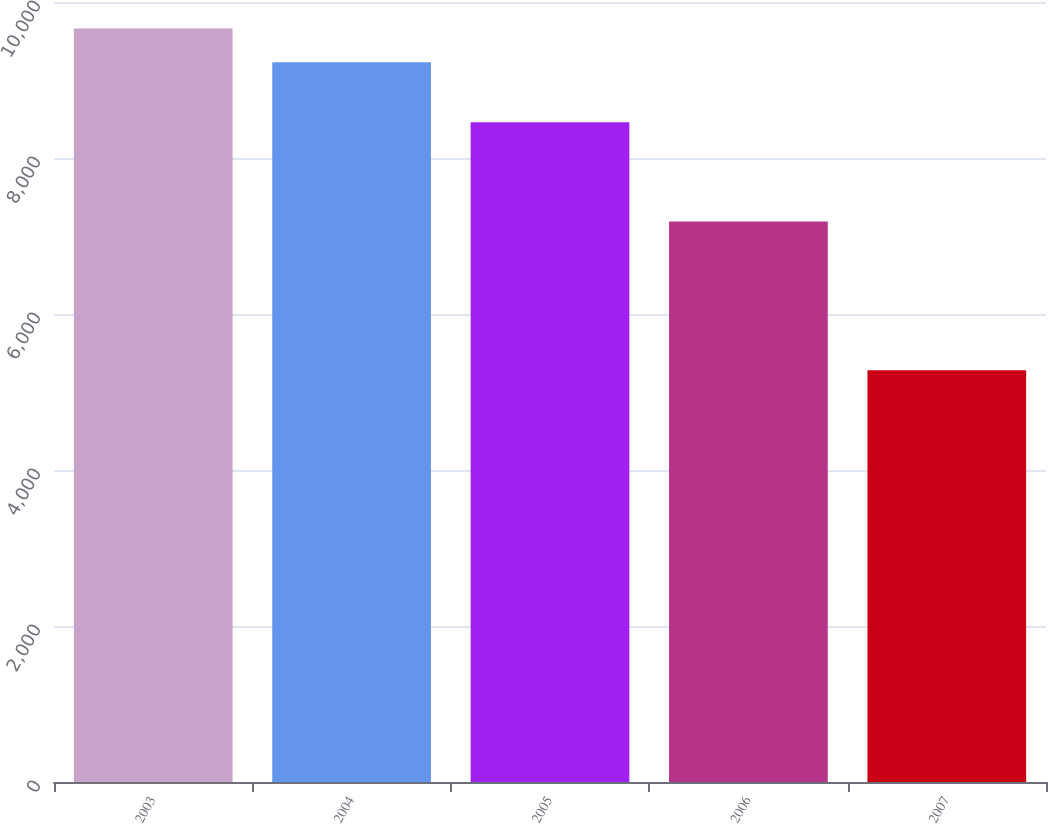<chart> <loc_0><loc_0><loc_500><loc_500><bar_chart><fcel>2003<fcel>2004<fcel>2005<fcel>2006<fcel>2007<nl><fcel>9659.9<fcel>9229<fcel>8457<fcel>7186<fcel>5280<nl></chart> 